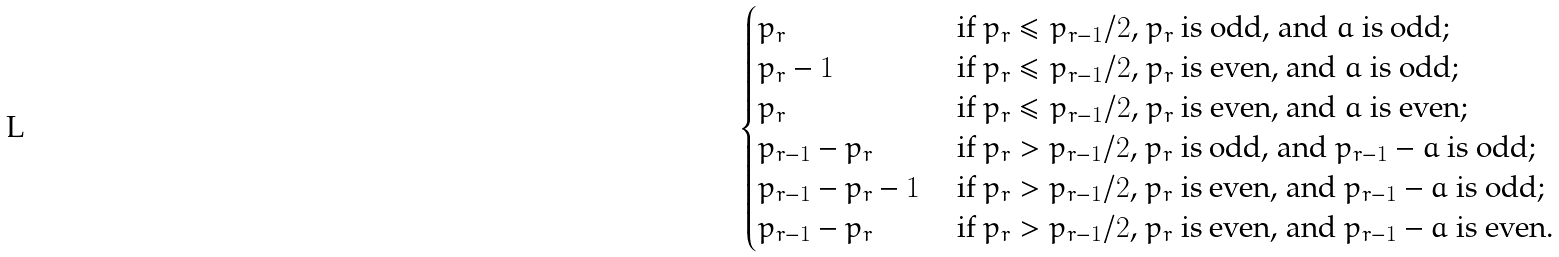<formula> <loc_0><loc_0><loc_500><loc_500>\begin{cases} p _ { r } & \text { if $p_{r} \leq p_{r-1}/2$, $p_{r}$ is odd,    and $a$ is odd;} \\ p _ { r } - 1 & \text { if $p_{r} \leq p_{r-1}/2$, $p_{r}$ is even,    and $a$ is odd;} \\ p _ { r } & \text { if $p_{r} \leq p_{r-1}/2$, $p_{r}$ is even,    and $a$ is even;} \\ p _ { r - 1 } - p _ { r } & \text { if $p_{r} > p_{r-1}/2$,     $p_{r}$ is odd, and $p_{r-1} - a$ is odd;} \\ p _ { r - 1 } - p _ { r } - 1 & \text { if $p_{r} > p_{r-1}/2$,     $p_{r}$ is even, and $p_{r-1} - a$ is odd;} \\ p _ { r - 1 } - p _ { r } & \text { if $p_{r} > p_{r-1}/2$,     $p_{r}$ is even, and $p_{r-1} - a$ is even.} \end{cases}</formula> 